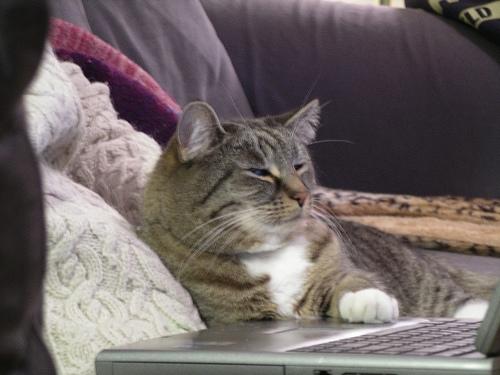Where is the cat?
Quick response, please. Couch. What is this animal doing?
Quick response, please. Resting. What is the cat sitting in?
Answer briefly. Couch. Is this a Tabby cat?
Keep it brief. Yes. Where is the cat's front paw?
Answer briefly. On laptop. Is the cat wide awake?
Write a very short answer. No. What color cat is this?
Write a very short answer. Gray. What color is the cat?
Short answer required. Gray. 